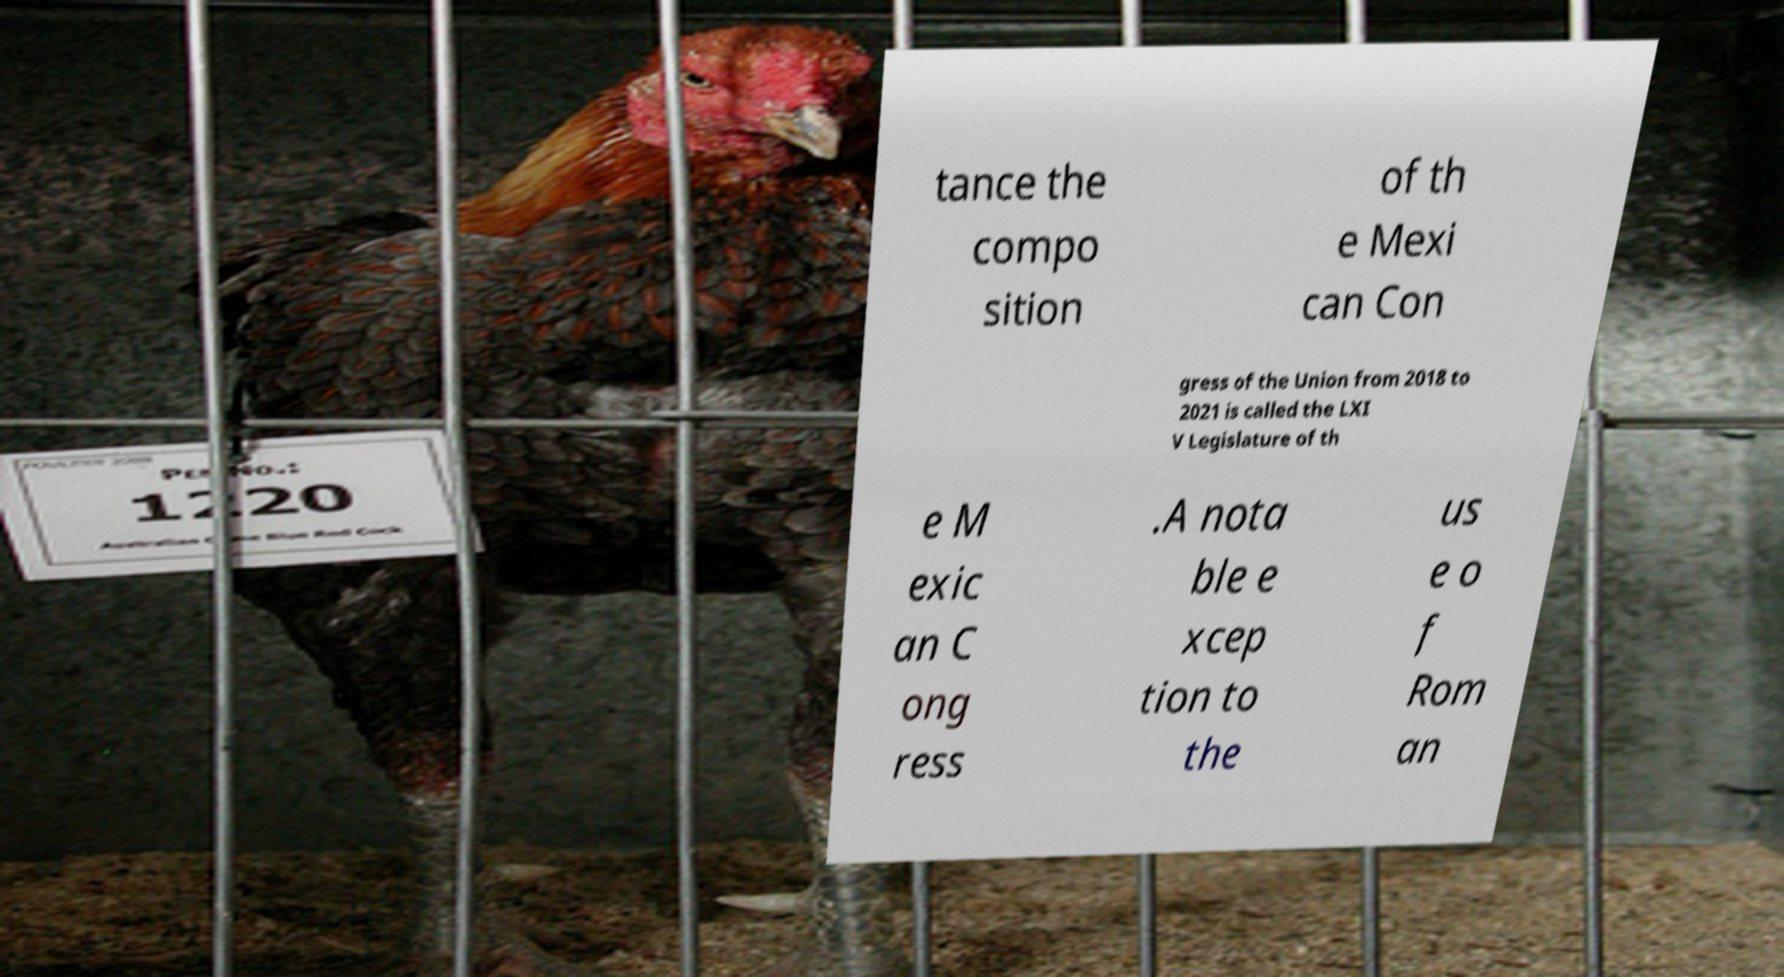Can you accurately transcribe the text from the provided image for me? tance the compo sition of th e Mexi can Con gress of the Union from 2018 to 2021 is called the LXI V Legislature of th e M exic an C ong ress .A nota ble e xcep tion to the us e o f Rom an 